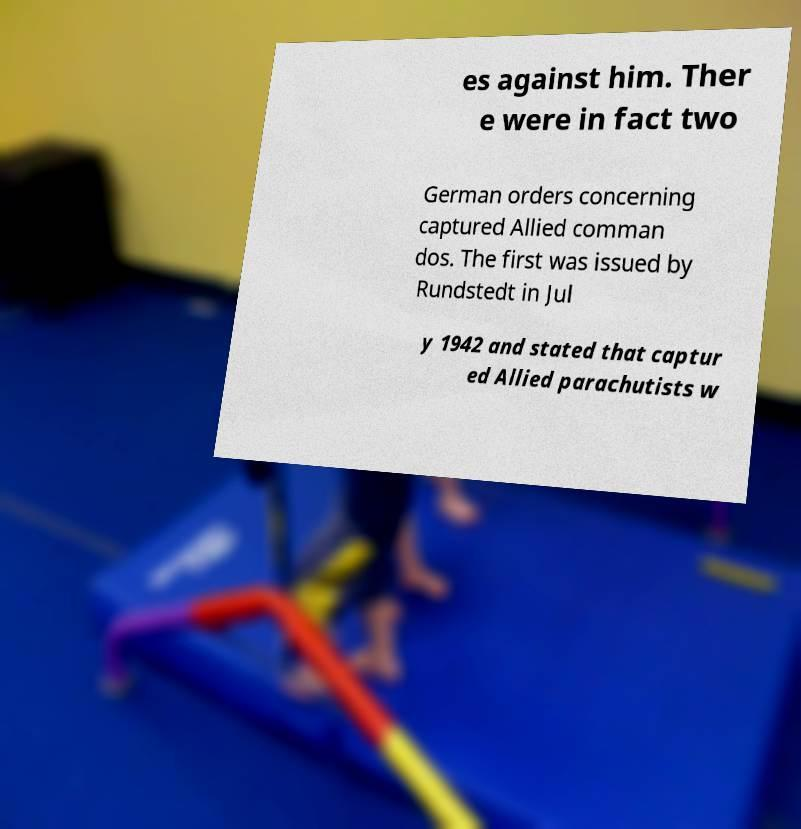Can you read and provide the text displayed in the image?This photo seems to have some interesting text. Can you extract and type it out for me? es against him. Ther e were in fact two German orders concerning captured Allied comman dos. The first was issued by Rundstedt in Jul y 1942 and stated that captur ed Allied parachutists w 